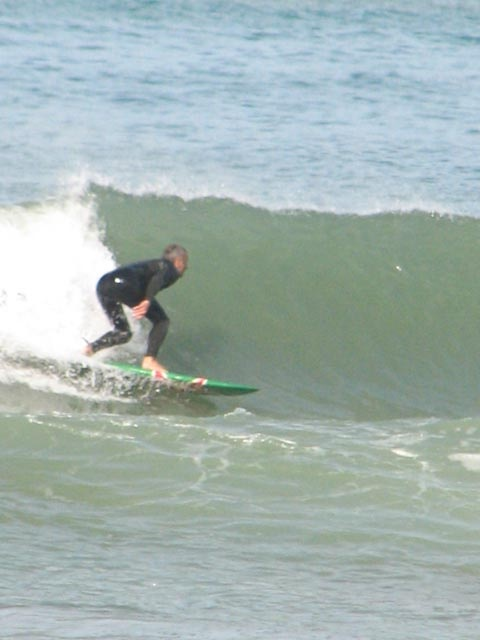Describe the objects in this image and their specific colors. I can see people in lightblue, gray, black, purple, and darkgray tones and surfboard in lightblue, gray, teal, darkgray, and lightgreen tones in this image. 